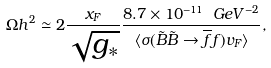<formula> <loc_0><loc_0><loc_500><loc_500>\Omega h ^ { 2 } \simeq 2 \frac { x _ { F } } { \sqrt { g _ { \ast } } } \frac { 8 . 7 \times 1 0 ^ { - 1 1 } \ G e V ^ { - 2 } } { \langle \sigma ( \tilde { B } \tilde { B } \rightarrow \overline { f } f ) v _ { F } \rangle } ,</formula> 